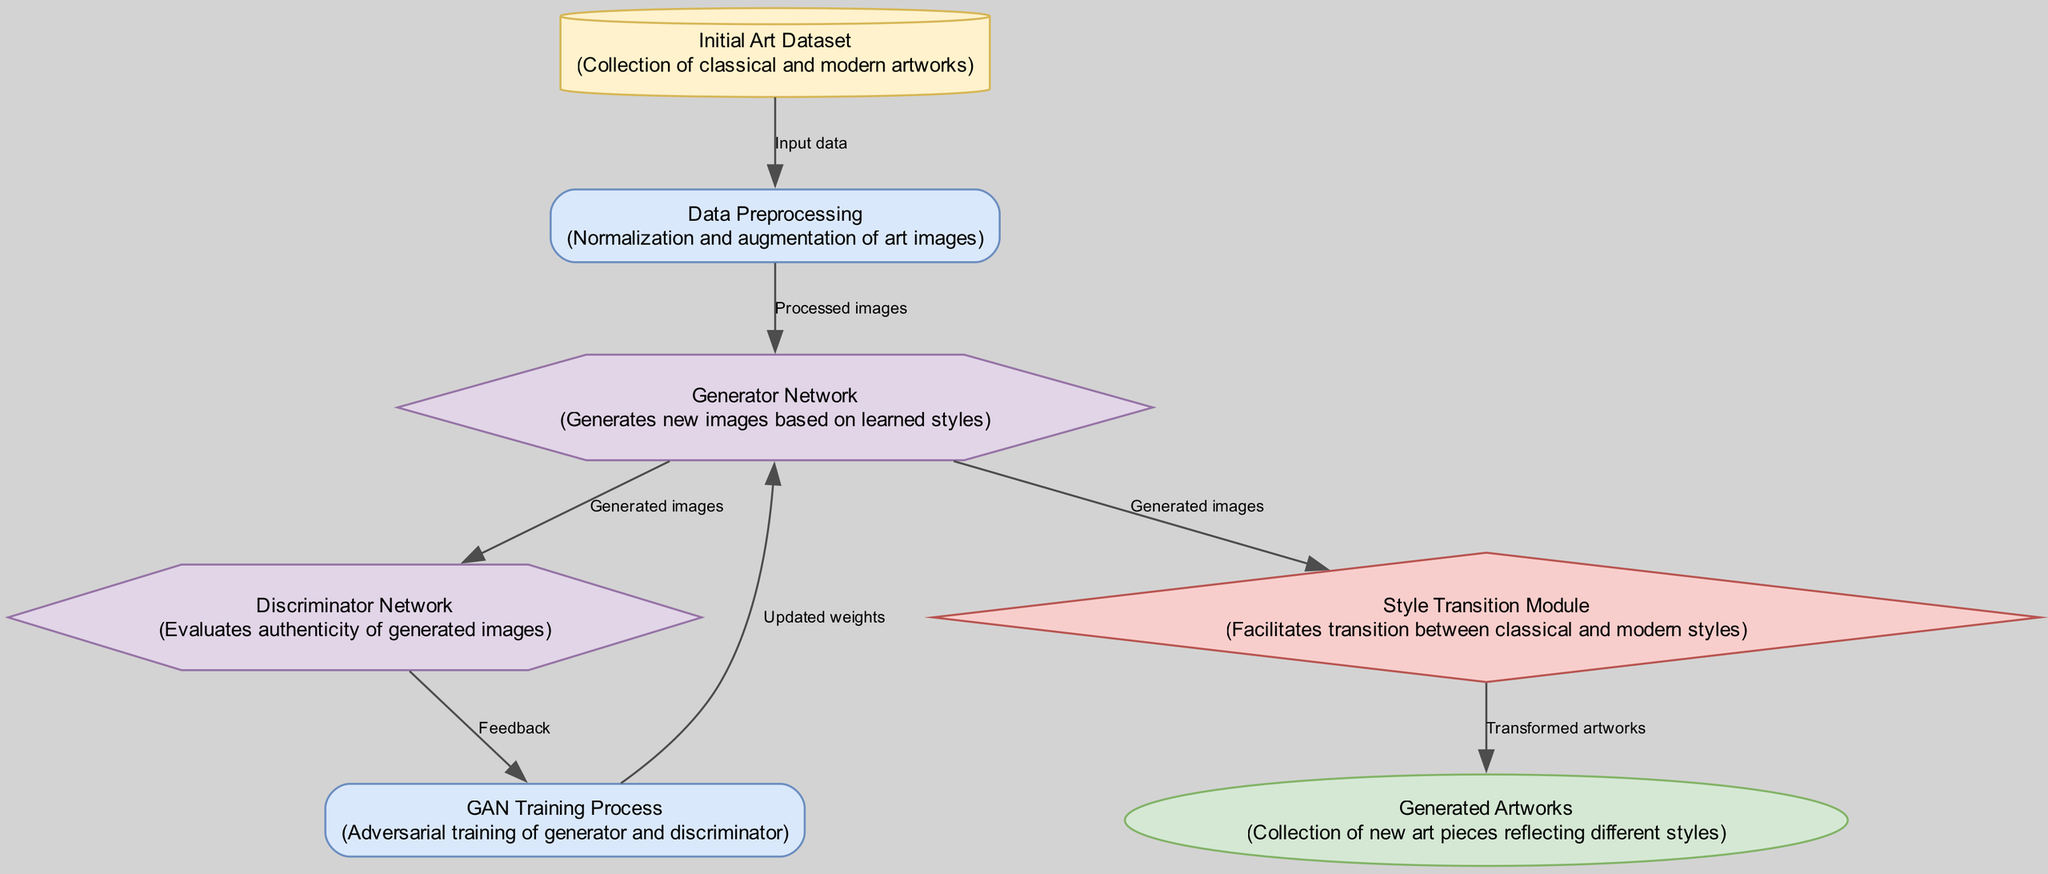What is the initial input to the process? The initial input to the process is the "Initial Art Dataset", which is a collection of classical and modern artworks.
Answer: Initial Art Dataset How many nodes are there in the diagram? There are a total of seven nodes in the diagram that represent various components involved in the GAN process.
Answer: 7 What type of node is the "Style Transition Module"? The "Style Transition Module" is categorized as a component in the diagram, reflecting its role in facilitating transitions between styles.
Answer: component What feedback does the Discriminator Network provide? The Discriminator Network provides feedback to guide the training process, ensuring the generator improves its image generation.
Answer: Feedback What is the output of the GAN training process? The output of the GAN training process, after incorporating the generator's improvements, is the "Generated Artworks" reflecting various styles.
Answer: Generated Artworks How do images transition from the Generator Network to the Style Transition Module? Images transition from the Generator Network to the Style Transition Module through the generated images produced by the generator.
Answer: Generated images Which process comes before the Generator Network? The process that comes before the Generator Network is "Data Preprocessing," which prepares the images for the generator's input.
Answer: Data Preprocessing What do the generated artworks represent? The generated artworks represent a collection of new art pieces that illustrate different styles, showcasing the evolution of artistic styles.
Answer: new art pieces reflecting different styles Which network evaluates the authenticity of generated images? The network that evaluates the authenticity of generated images is the Discriminator Network, which assesses the quality of outputs from the Generator Network.
Answer: Discriminator Network 